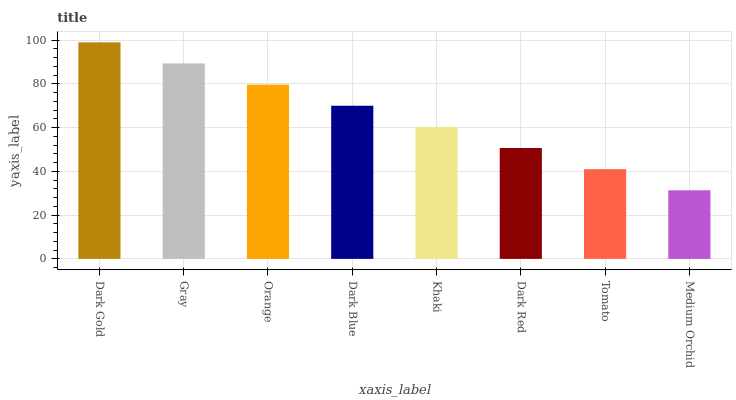Is Medium Orchid the minimum?
Answer yes or no. Yes. Is Dark Gold the maximum?
Answer yes or no. Yes. Is Gray the minimum?
Answer yes or no. No. Is Gray the maximum?
Answer yes or no. No. Is Dark Gold greater than Gray?
Answer yes or no. Yes. Is Gray less than Dark Gold?
Answer yes or no. Yes. Is Gray greater than Dark Gold?
Answer yes or no. No. Is Dark Gold less than Gray?
Answer yes or no. No. Is Dark Blue the high median?
Answer yes or no. Yes. Is Khaki the low median?
Answer yes or no. Yes. Is Dark Red the high median?
Answer yes or no. No. Is Medium Orchid the low median?
Answer yes or no. No. 